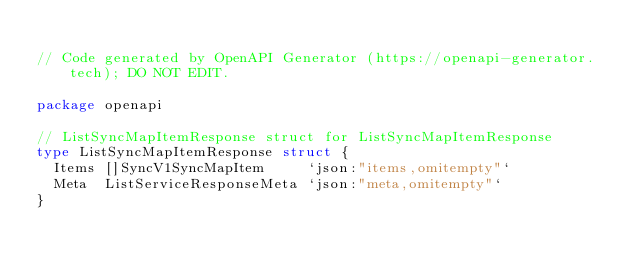<code> <loc_0><loc_0><loc_500><loc_500><_Go_>
// Code generated by OpenAPI Generator (https://openapi-generator.tech); DO NOT EDIT.

package openapi

// ListSyncMapItemResponse struct for ListSyncMapItemResponse
type ListSyncMapItemResponse struct {
	Items []SyncV1SyncMapItem     `json:"items,omitempty"`
	Meta  ListServiceResponseMeta `json:"meta,omitempty"`
}
</code> 